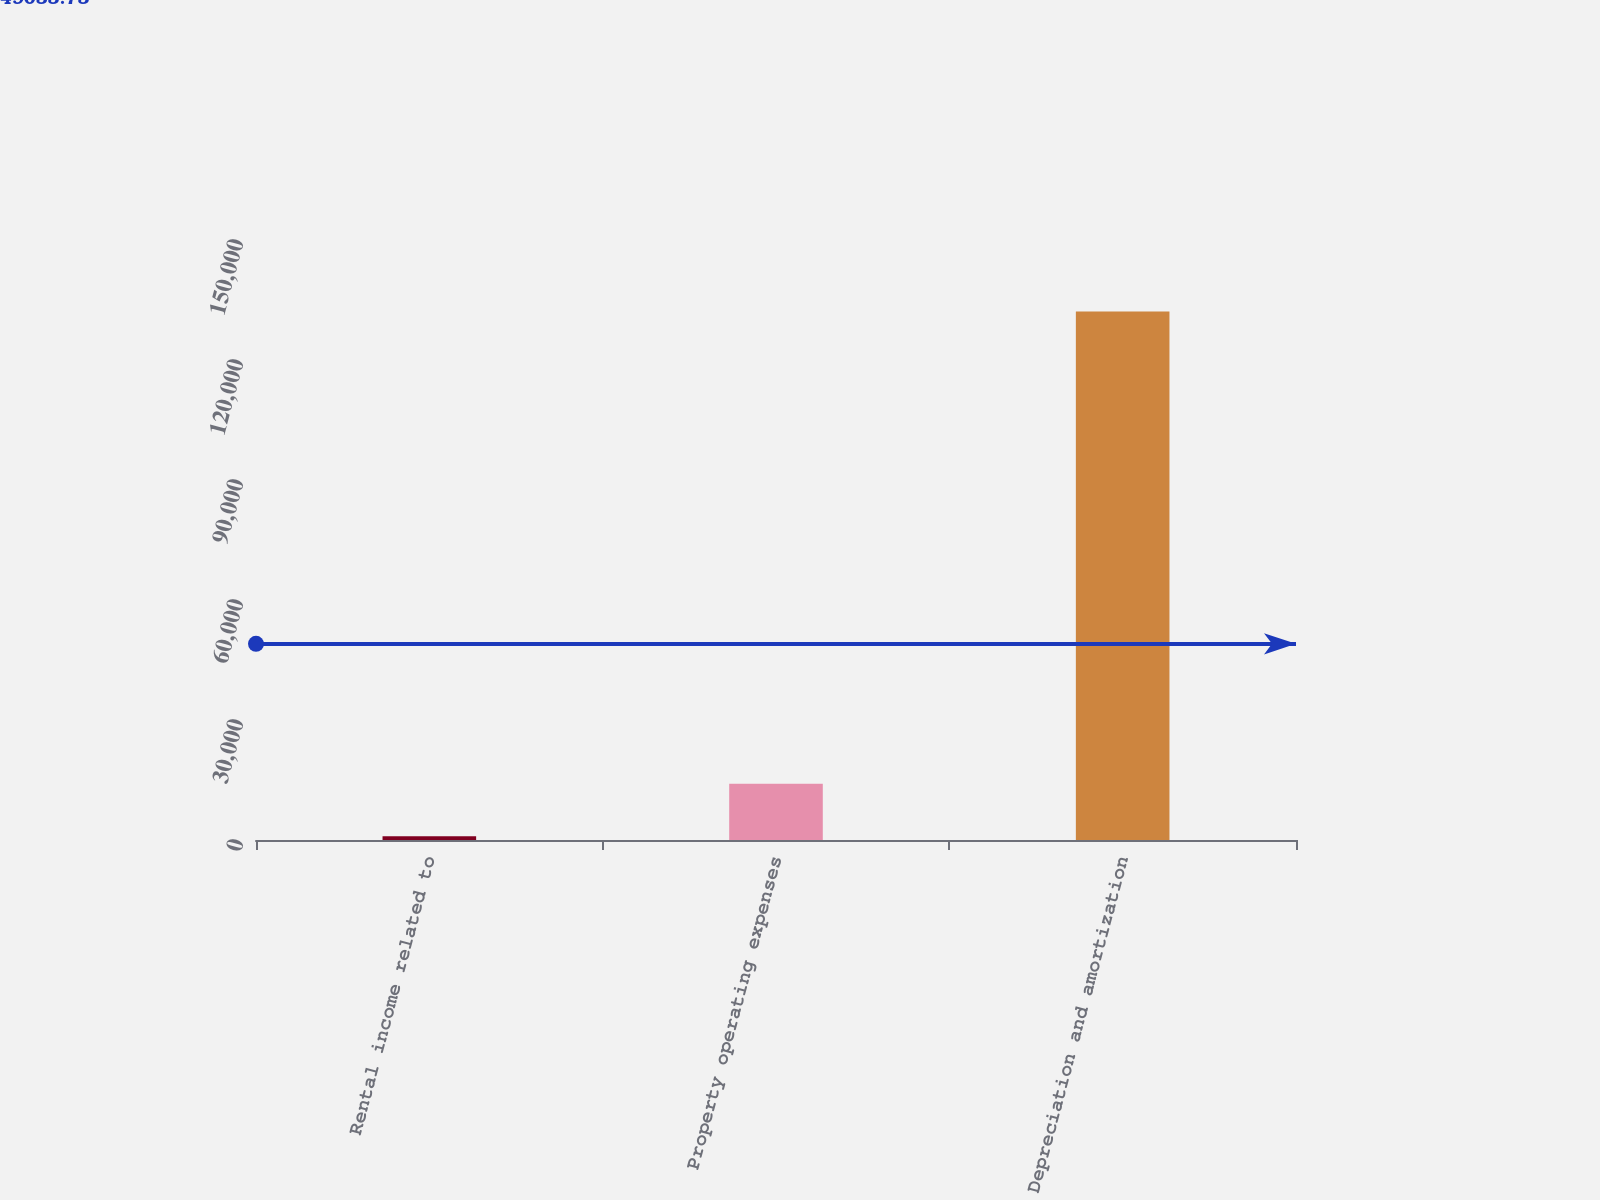Convert chart. <chart><loc_0><loc_0><loc_500><loc_500><bar_chart><fcel>Rental income related to<fcel>Property operating expenses<fcel>Depreciation and amortization<nl><fcel>919<fcel>14041.2<fcel>132141<nl></chart> 